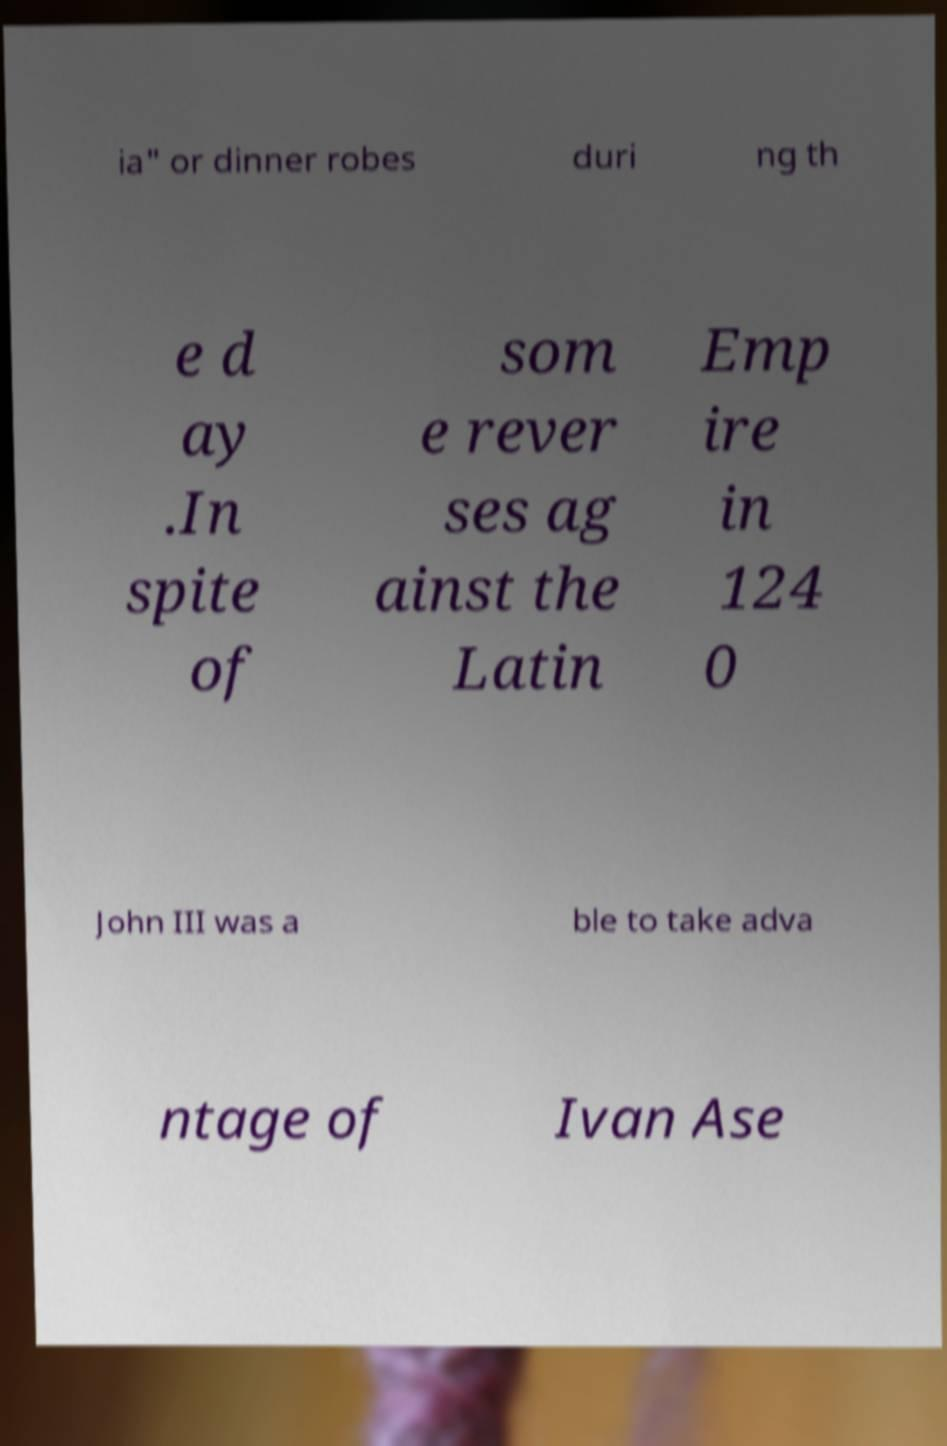There's text embedded in this image that I need extracted. Can you transcribe it verbatim? ia" or dinner robes duri ng th e d ay .In spite of som e rever ses ag ainst the Latin Emp ire in 124 0 John III was a ble to take adva ntage of Ivan Ase 